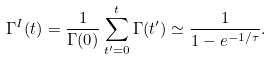Convert formula to latex. <formula><loc_0><loc_0><loc_500><loc_500>\Gamma ^ { I } ( t ) = \frac { 1 } { \Gamma ( 0 ) } \sum _ { t ^ { \prime } = 0 } ^ { t } \Gamma ( t ^ { \prime } ) \simeq \frac { 1 } { 1 - e ^ { - 1 / \tau } } .</formula> 